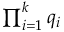<formula> <loc_0><loc_0><loc_500><loc_500>\prod _ { i = 1 } ^ { k } q _ { i }</formula> 